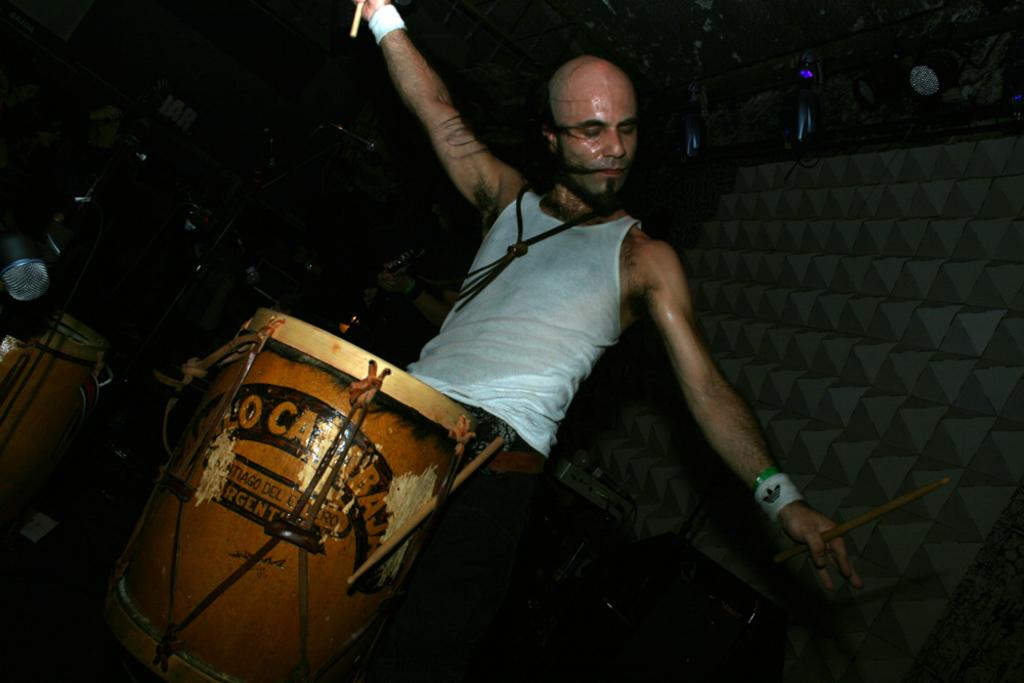What is the main subject of the image? There is a man in the image. What is the man holding in his hands? The man is holding sticks in his hands. What type of musical instruments can be seen in the image? There are drums in the image. What part of a person's body is visible in the image? A person's hands are visible in the image. How would you describe the lighting in the image? The background of the image is dark. How does the man increase the volume of the drums in the image? The image does not show the man increasing the volume of the drums; it only shows him holding sticks. What type of wind instrument is being played in the image? There is no wind instrument present in the image. 